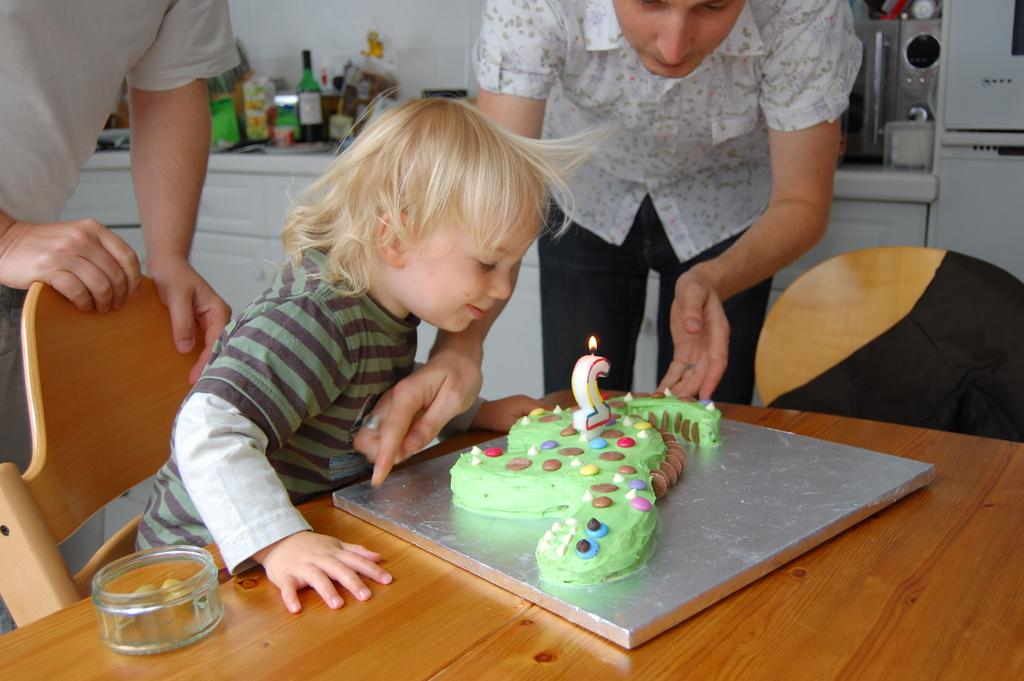What is the main subject of the image? The main subject of the image is a kid. What is the kid doing in the image? The kid is blowing a candle in the image. Where is the candle located? The candle is on a cake in the image. What surface is the cake placed on? The cake is on a table in the image. What type of flower is resting on the kid's knee in the image? There is no flower present in the image, nor is there any mention of a knee. 